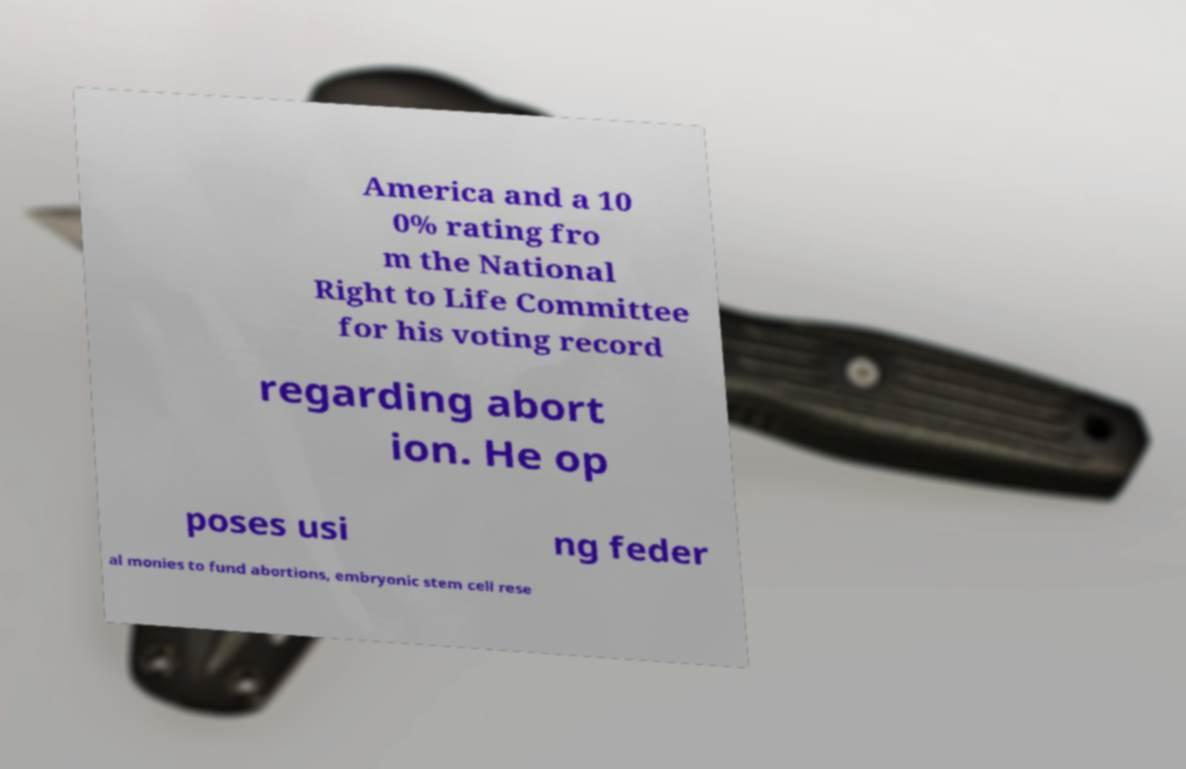Please read and relay the text visible in this image. What does it say? America and a 10 0% rating fro m the National Right to Life Committee for his voting record regarding abort ion. He op poses usi ng feder al monies to fund abortions, embryonic stem cell rese 